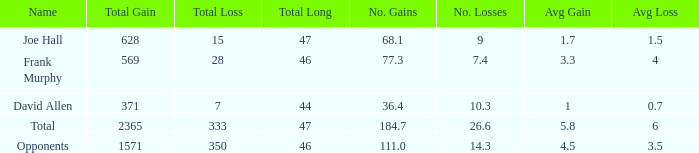Which Avg/G has a Name of david allen, and a Gain larger than 371? None. 